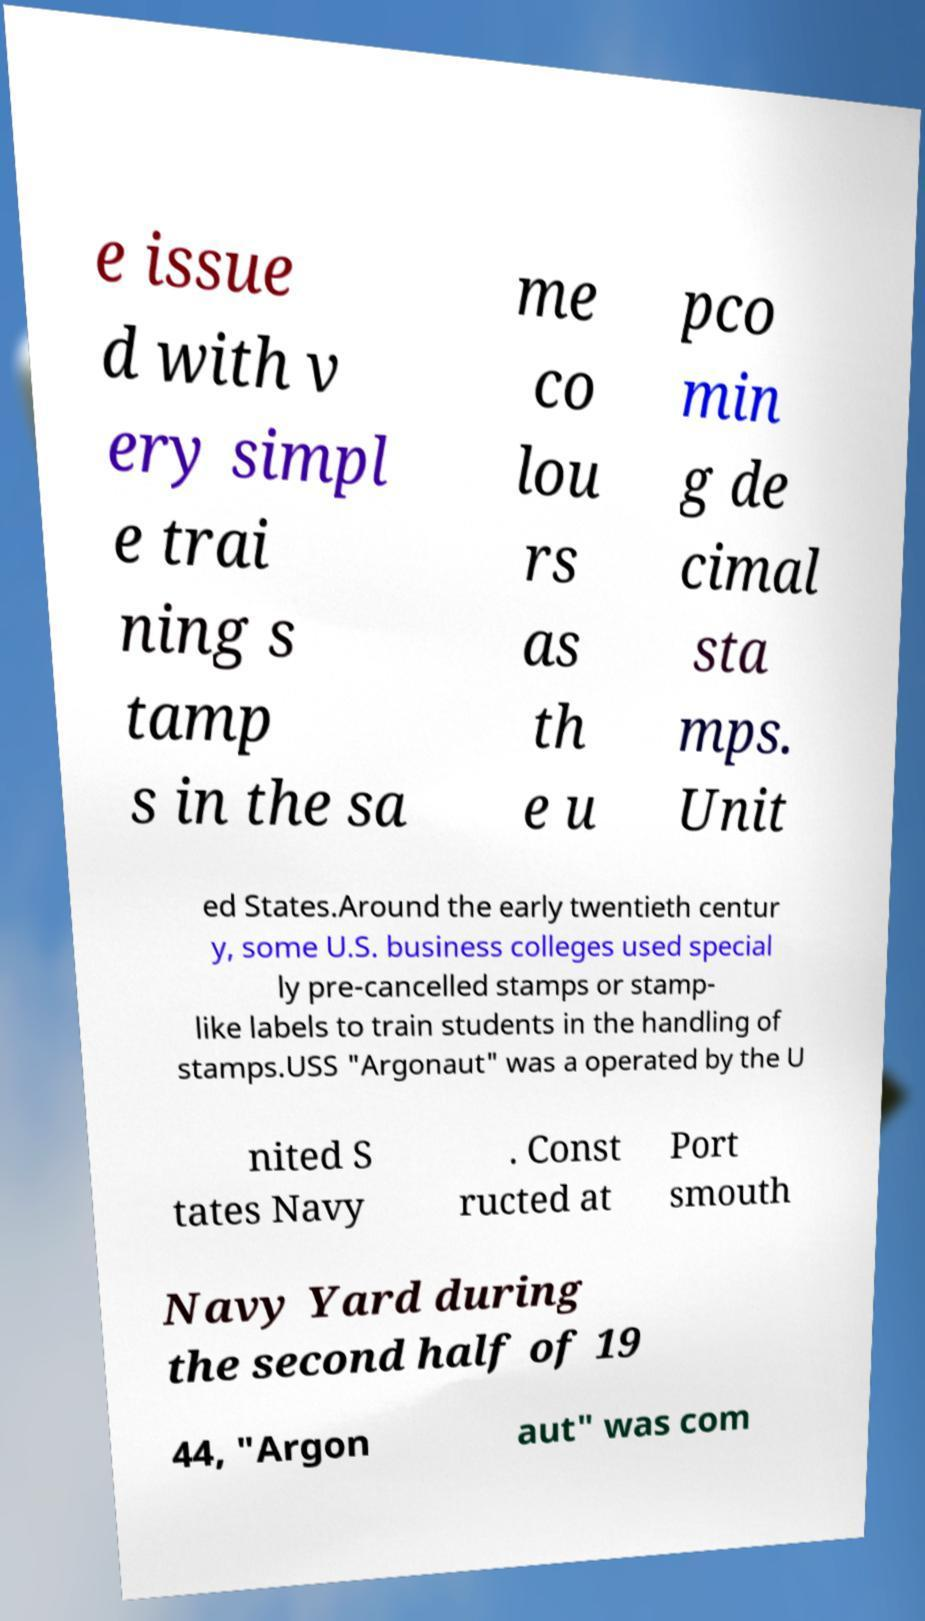I need the written content from this picture converted into text. Can you do that? e issue d with v ery simpl e trai ning s tamp s in the sa me co lou rs as th e u pco min g de cimal sta mps. Unit ed States.Around the early twentieth centur y, some U.S. business colleges used special ly pre-cancelled stamps or stamp- like labels to train students in the handling of stamps.USS "Argonaut" was a operated by the U nited S tates Navy . Const ructed at Port smouth Navy Yard during the second half of 19 44, "Argon aut" was com 